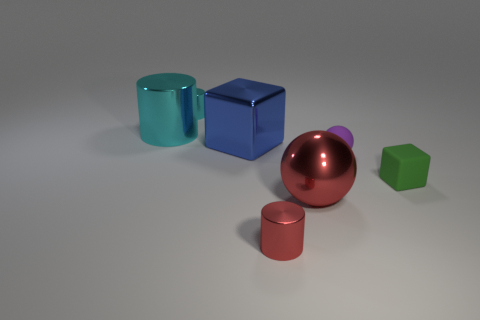Subtract all blue spheres. How many cyan cylinders are left? 2 Subtract all tiny metallic cylinders. How many cylinders are left? 1 Subtract 1 cylinders. How many cylinders are left? 2 Add 1 red spheres. How many objects exist? 8 Subtract all spheres. How many objects are left? 5 Subtract 0 gray cubes. How many objects are left? 7 Subtract all tiny purple matte objects. Subtract all large things. How many objects are left? 3 Add 2 metal blocks. How many metal blocks are left? 3 Add 5 purple rubber objects. How many purple rubber objects exist? 6 